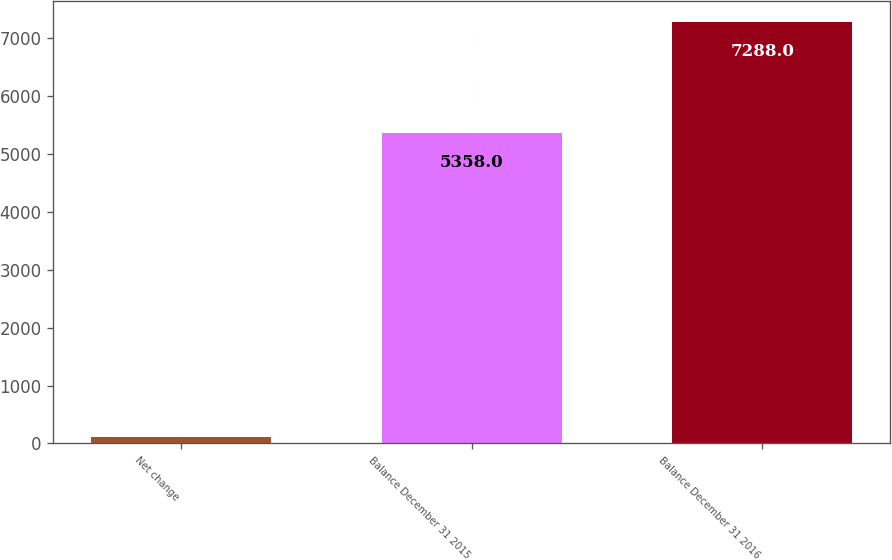Convert chart to OTSL. <chart><loc_0><loc_0><loc_500><loc_500><bar_chart><fcel>Net change<fcel>Balance December 31 2015<fcel>Balance December 31 2016<nl><fcel>110<fcel>5358<fcel>7288<nl></chart> 